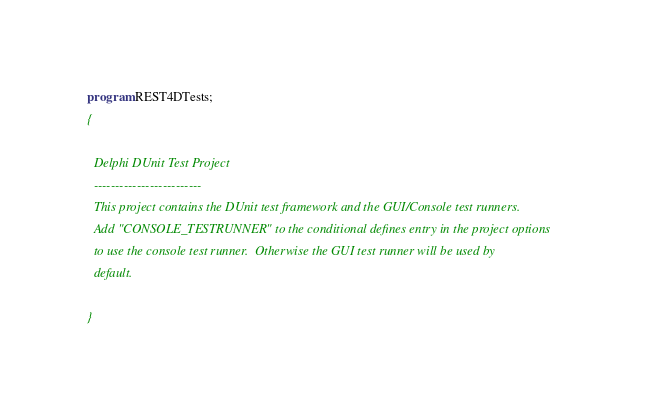<code> <loc_0><loc_0><loc_500><loc_500><_Pascal_>program REST4DTests;
{

  Delphi DUnit Test Project
  -------------------------
  This project contains the DUnit test framework and the GUI/Console test runners.
  Add "CONSOLE_TESTRUNNER" to the conditional defines entry in the project options
  to use the console test runner.  Otherwise the GUI test runner will be used by
  default.

}
</code> 